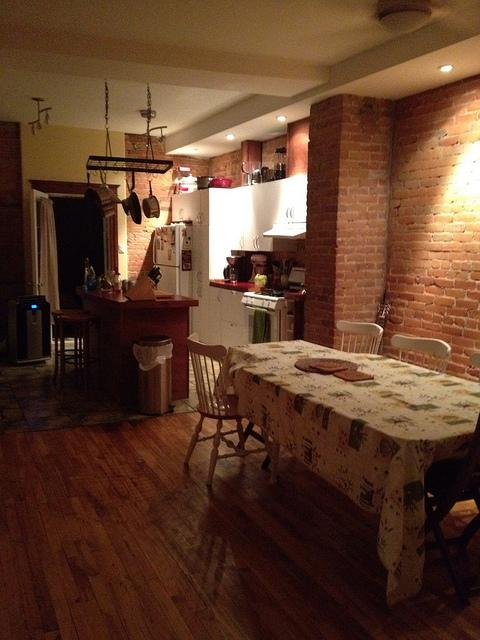What is next to the chair?

Choices:
A) pumpkin
B) apple pie
C) tablecloth
D) baby tablecloth 